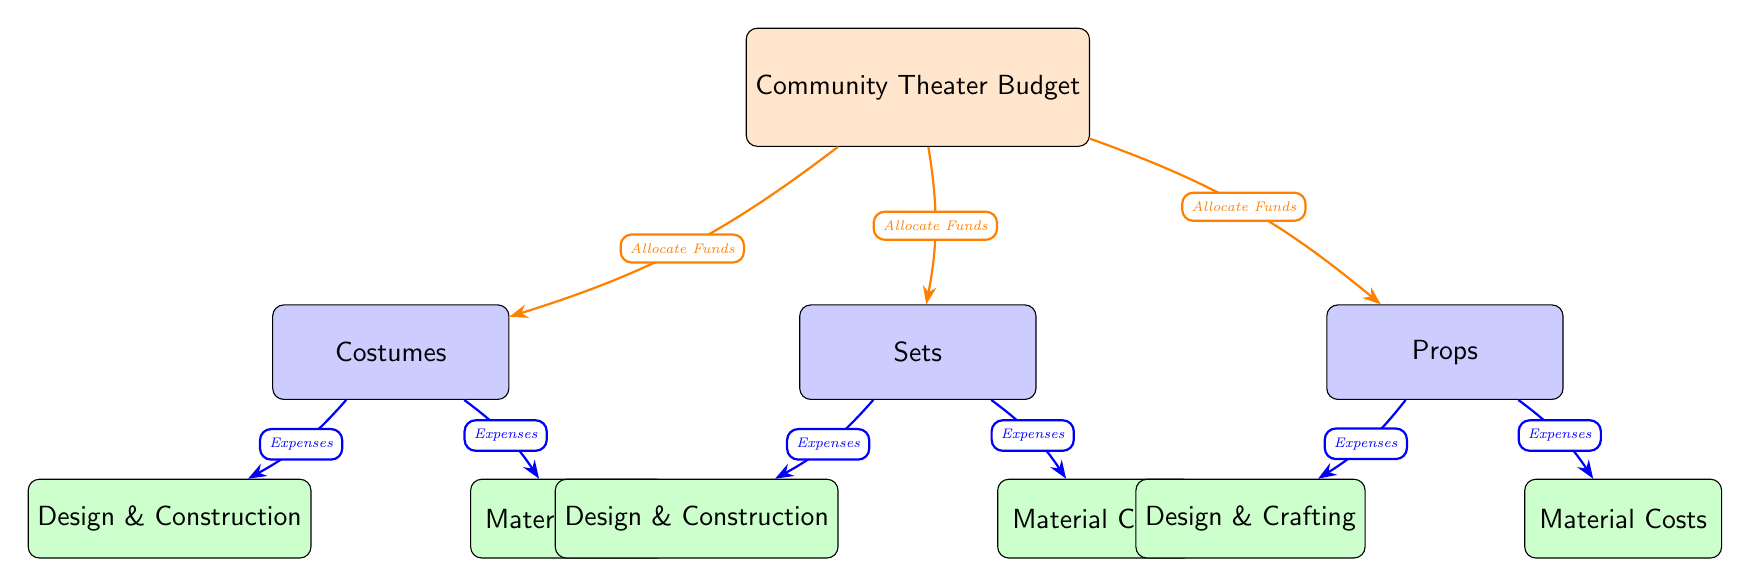What is the main category of the budget? The main category node is labeled "Community Theater Budget," which indicates that this diagram represents the overall budget for a community theater.
Answer: Community Theater Budget How many categories are under the main budget? The diagram shows three category nodes branching out from the main budget: Costumes, Sets, and Props, making it a total of three categories.
Answer: 3 What are the two subcategories under costumes? Under the Costumes category, there are two subcategory nodes: Design & Construction and Material Costs, which detail the allocation of funds for costumes.
Answer: Design & Construction, Material Costs Which category has more subcategories? All categories (Costumes, Sets, Props) have two subcategories each, so none of them has more subcategories than the others, making this a tie in terms of subcategory count.
Answer: None What does the arrow labeled “Expenses” connect to in the Sets category? The diagram shows that the arrow labeled "Expenses" connects the Sets category to both its subcategories: Design & Construction and Material Costs, indicating where the expenses are allocated.
Answer: Design & Construction, Material Costs How do the subcategories for Props differ from those for Sets? While both sets and props include Design and Material subcategories, specifically for props, the focus is on "Design & Crafting" compared to "Design & Construction" for sets, indicating a slight difference in terminology reflecting the crafting aspect in props.
Answer: Design & Crafting What does the arrow labeled “Allocate Funds” indicate? The arrows labeled "Allocate Funds" direct from the main budget to each of the three categories (Costumes, Sets, Props), highlighting that funds are being distributed to these areas of the community theater budget.
Answer: Allocate Funds In which direction do the arrows flow from the main budget to the categories? The arrows flow downward from the main budget node to the three category nodes (Costumes, Sets, Props), indicating the distribution of funds from the main budget to these specific areas.
Answer: Downward 